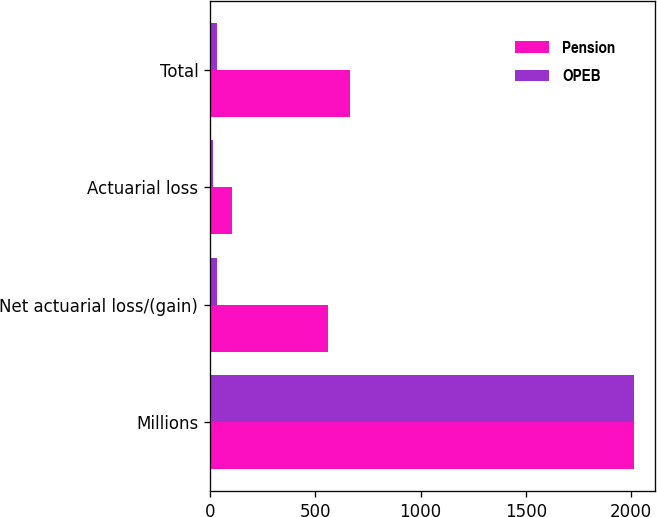Convert chart. <chart><loc_0><loc_0><loc_500><loc_500><stacked_bar_chart><ecel><fcel>Millions<fcel>Net actuarial loss/(gain)<fcel>Actuarial loss<fcel>Total<nl><fcel>Pension<fcel>2013<fcel>561<fcel>106<fcel>667<nl><fcel>OPEB<fcel>2013<fcel>34<fcel>15<fcel>33<nl></chart> 